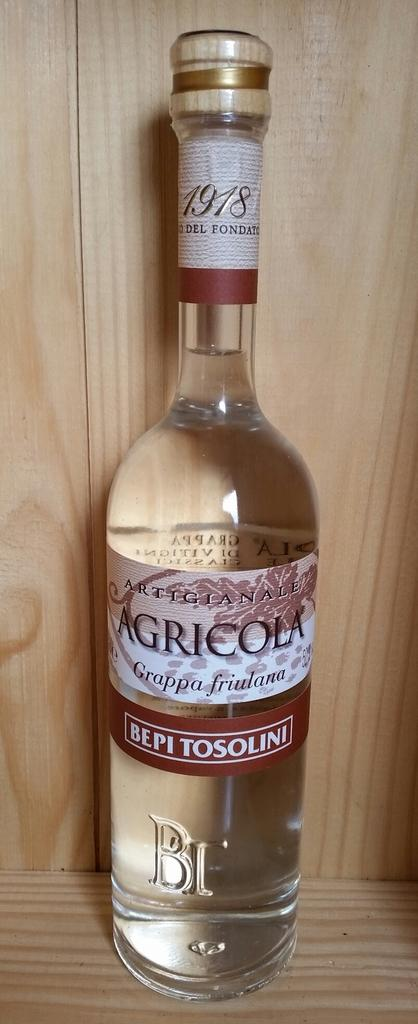<image>
Create a compact narrative representing the image presented. a bottle of agricola grappa fruilana bepi tosolini 